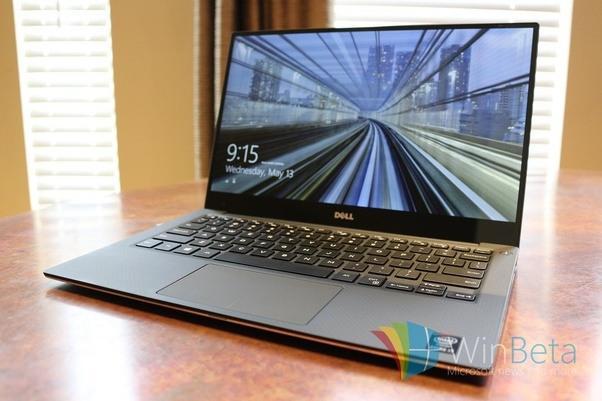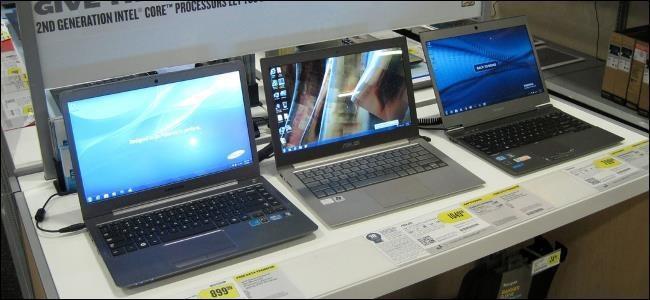The first image is the image on the left, the second image is the image on the right. Considering the images on both sides, is "At least one image contains a single laptop." valid? Answer yes or no. Yes. The first image is the image on the left, the second image is the image on the right. Analyze the images presented: Is the assertion "An image shows a row of at least three open laptops, with screens angled facing rightward." valid? Answer yes or no. Yes. 